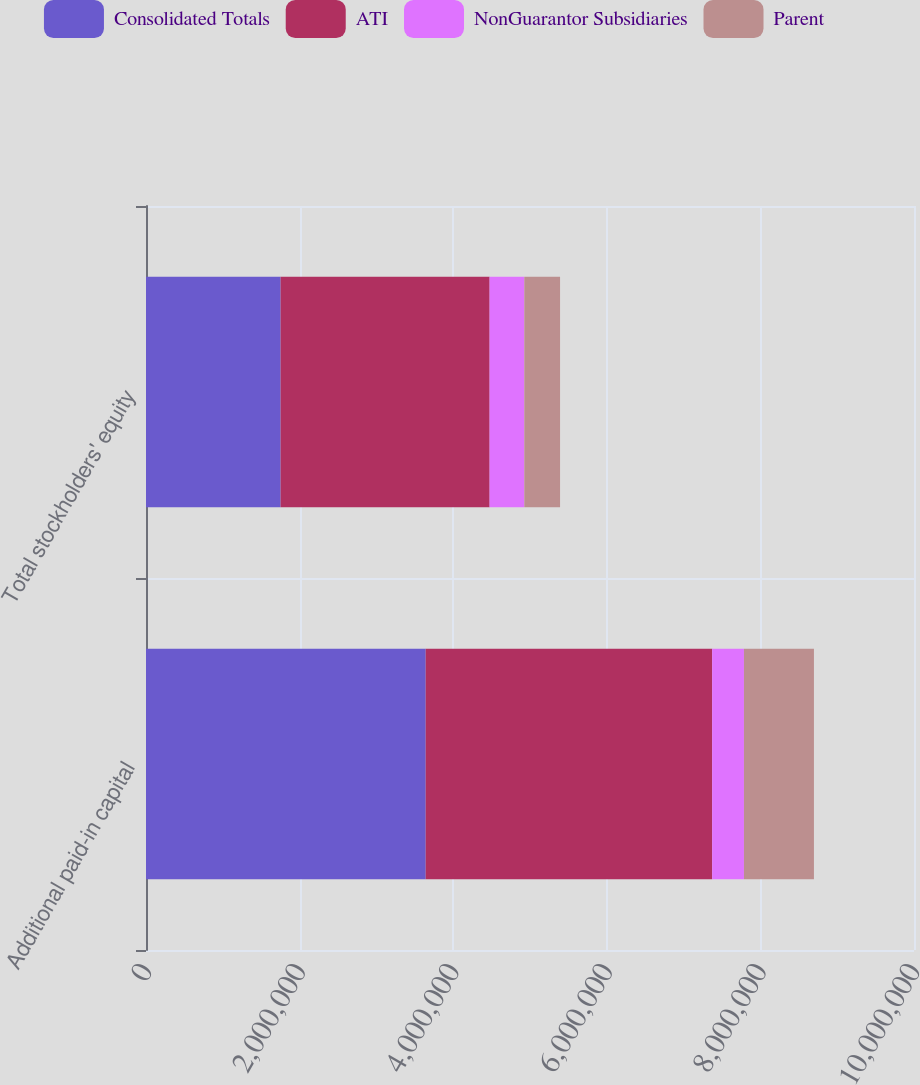Convert chart. <chart><loc_0><loc_0><loc_500><loc_500><stacked_bar_chart><ecel><fcel>Additional paid-in capital<fcel>Total stockholders' equity<nl><fcel>Consolidated Totals<fcel>3.64202e+06<fcel>1.75261e+06<nl><fcel>ATI<fcel>3.72982e+06<fcel>2.72141e+06<nl><fcel>NonGuarantor Subsidiaries<fcel>414037<fcel>451940<nl><fcel>Parent<fcel>911202<fcel>465559<nl></chart> 